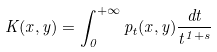Convert formula to latex. <formula><loc_0><loc_0><loc_500><loc_500>K ( x , y ) = \int _ { 0 } ^ { + \infty } p _ { t } ( x , y ) \frac { d t } { t ^ { 1 + s } }</formula> 